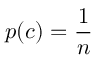Convert formula to latex. <formula><loc_0><loc_0><loc_500><loc_500>p ( c ) = \frac { 1 } { n }</formula> 